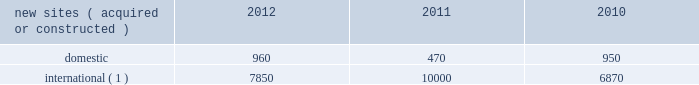Continue to be deployed as wireless service providers are beginning their investments in 3g data networks .
Similarly , in ghana and uganda , wireless service providers continue to build out their voice and data networks in order to satisfy increasing demand for wireless services .
In south africa , where voice networks are in a more advanced stage of development , carriers are beginning to deploy 3g data networks across spectrum acquired in recent spectrum auctions .
In mexico and brazil , where nationwide voice networks have also been deployed , some incumbent wireless service providers continue to invest in their 3g data networks , and recent spectrum auctions have enabled other incumbent wireless service providers to begin their initial investments in 3g data networks .
In markets such as chile , peru and colombia , recent or anticipated spectrum auctions are expected to drive investment in nationwide voice and 3g data networks .
In germany , our most mature international wireless market , demand is currently being driven by a government-mandated rural fourth generation network build-out , as well as other tenant initiatives to deploy next generation wireless services .
We believe incremental demand for our tower sites will continue in our international markets as wireless service providers seek to remain competitive by increasing the coverage of their networks while also investing in next generation data networks .
Rental and management operations new site revenue growth .
During the year ended december 31 , 2012 , we grew our portfolio of communications real estate through acquisitions and construction activities , including the acquisition and construction of approximately 8810 sites .
In a majority of our international markets , the acquisition or construction of new sites results in increased pass-through revenues and expenses .
We continue to evaluate opportunities to acquire larger communications real estate portfolios , both domestically and internationally , to determine whether they meet our risk adjusted hurdle rates and whether we believe we can effectively integrate them into our existing portfolio. .
( 1 ) the majority of sites acquired or constructed in 2012 were in brazil , germany , india and uganda ; in 2011 were in brazil , colombia , ghana , india , mexico and south africa ; and in 2010 were in chile , colombia , india and peru .
Network development services segment revenue growth .
As we continue to focus on growing our rental and management operations , we anticipate that our network development services revenue will continue to represent a relatively small percentage of our total revenues .
Through our network development services segment , we offer tower-related services , including site acquisition , zoning and permitting services and structural analysis services , which primarily support our site leasing business and the addition of new tenants and equipment on our sites , including in connection with provider network upgrades .
Rental and management operations expenses .
Direct operating expenses incurred by our domestic and international rental and management segments include direct site level expenses and consist primarily of ground rent , property taxes , repairs and maintenance , security and power and fuel costs , some of which may be passed through to our tenants .
These segment direct operating expenses exclude all segment and corporate selling , general , administrative and development expenses , which are aggregated into one line item entitled selling , general , administrative and development expense in our consolidated statements of operations .
In general , our domestic and international rental and management segments selling , general , administrative and development expenses do not significantly increase as a result of adding incremental tenants to our legacy sites and typically increase only modestly year-over-year .
As a result , leasing additional space to new tenants on our legacy sites provides significant incremental cash flow .
We may incur additional segment selling , general , administrative and development expenses as we increase our presence in geographic areas where we have recently launched operations or are focused on expanding our portfolio .
Our profit margin growth is therefore positively impacted by the addition of new tenants to our legacy sites and can be temporarily diluted by our development activities. .
What was the ratio of the sites in 2011 for the domestic to international sites? 
Computations: (960 / 7850)
Answer: 0.12229. 